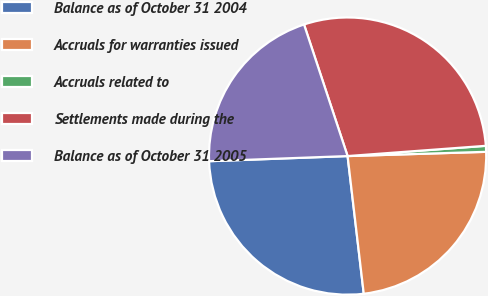<chart> <loc_0><loc_0><loc_500><loc_500><pie_chart><fcel>Balance as of October 31 2004<fcel>Accruals for warranties issued<fcel>Accruals related to<fcel>Settlements made during the<fcel>Balance as of October 31 2005<nl><fcel>26.27%<fcel>23.63%<fcel>0.69%<fcel>28.91%<fcel>20.5%<nl></chart> 